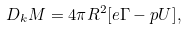Convert formula to latex. <formula><loc_0><loc_0><loc_500><loc_500>D _ { k } M = 4 \pi R ^ { 2 } [ e \Gamma - p U ] ,</formula> 